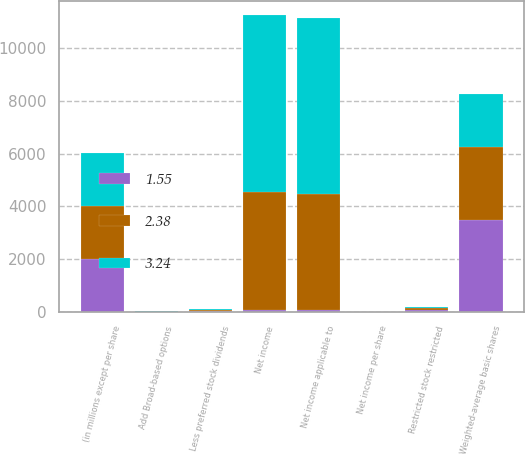<chart> <loc_0><loc_0><loc_500><loc_500><stacked_bar_chart><ecel><fcel>(in millions except per share<fcel>Net income<fcel>Less preferred stock dividends<fcel>Net income applicable to<fcel>Weighted-average basic shares<fcel>Net income per share<fcel>Add Broad-based options<fcel>Restricted stock restricted<nl><fcel>1.55<fcel>2005<fcel>63.65<fcel>13<fcel>63.65<fcel>3491.7<fcel>2.43<fcel>3.6<fcel>62<nl><fcel>2.38<fcel>2004<fcel>4466<fcel>52<fcel>4414<fcel>2779.9<fcel>1.59<fcel>5.4<fcel>65.3<nl><fcel>3.24<fcel>2003<fcel>6719<fcel>51<fcel>6668<fcel>2008.6<fcel>3.32<fcel>4.1<fcel>42.4<nl></chart> 